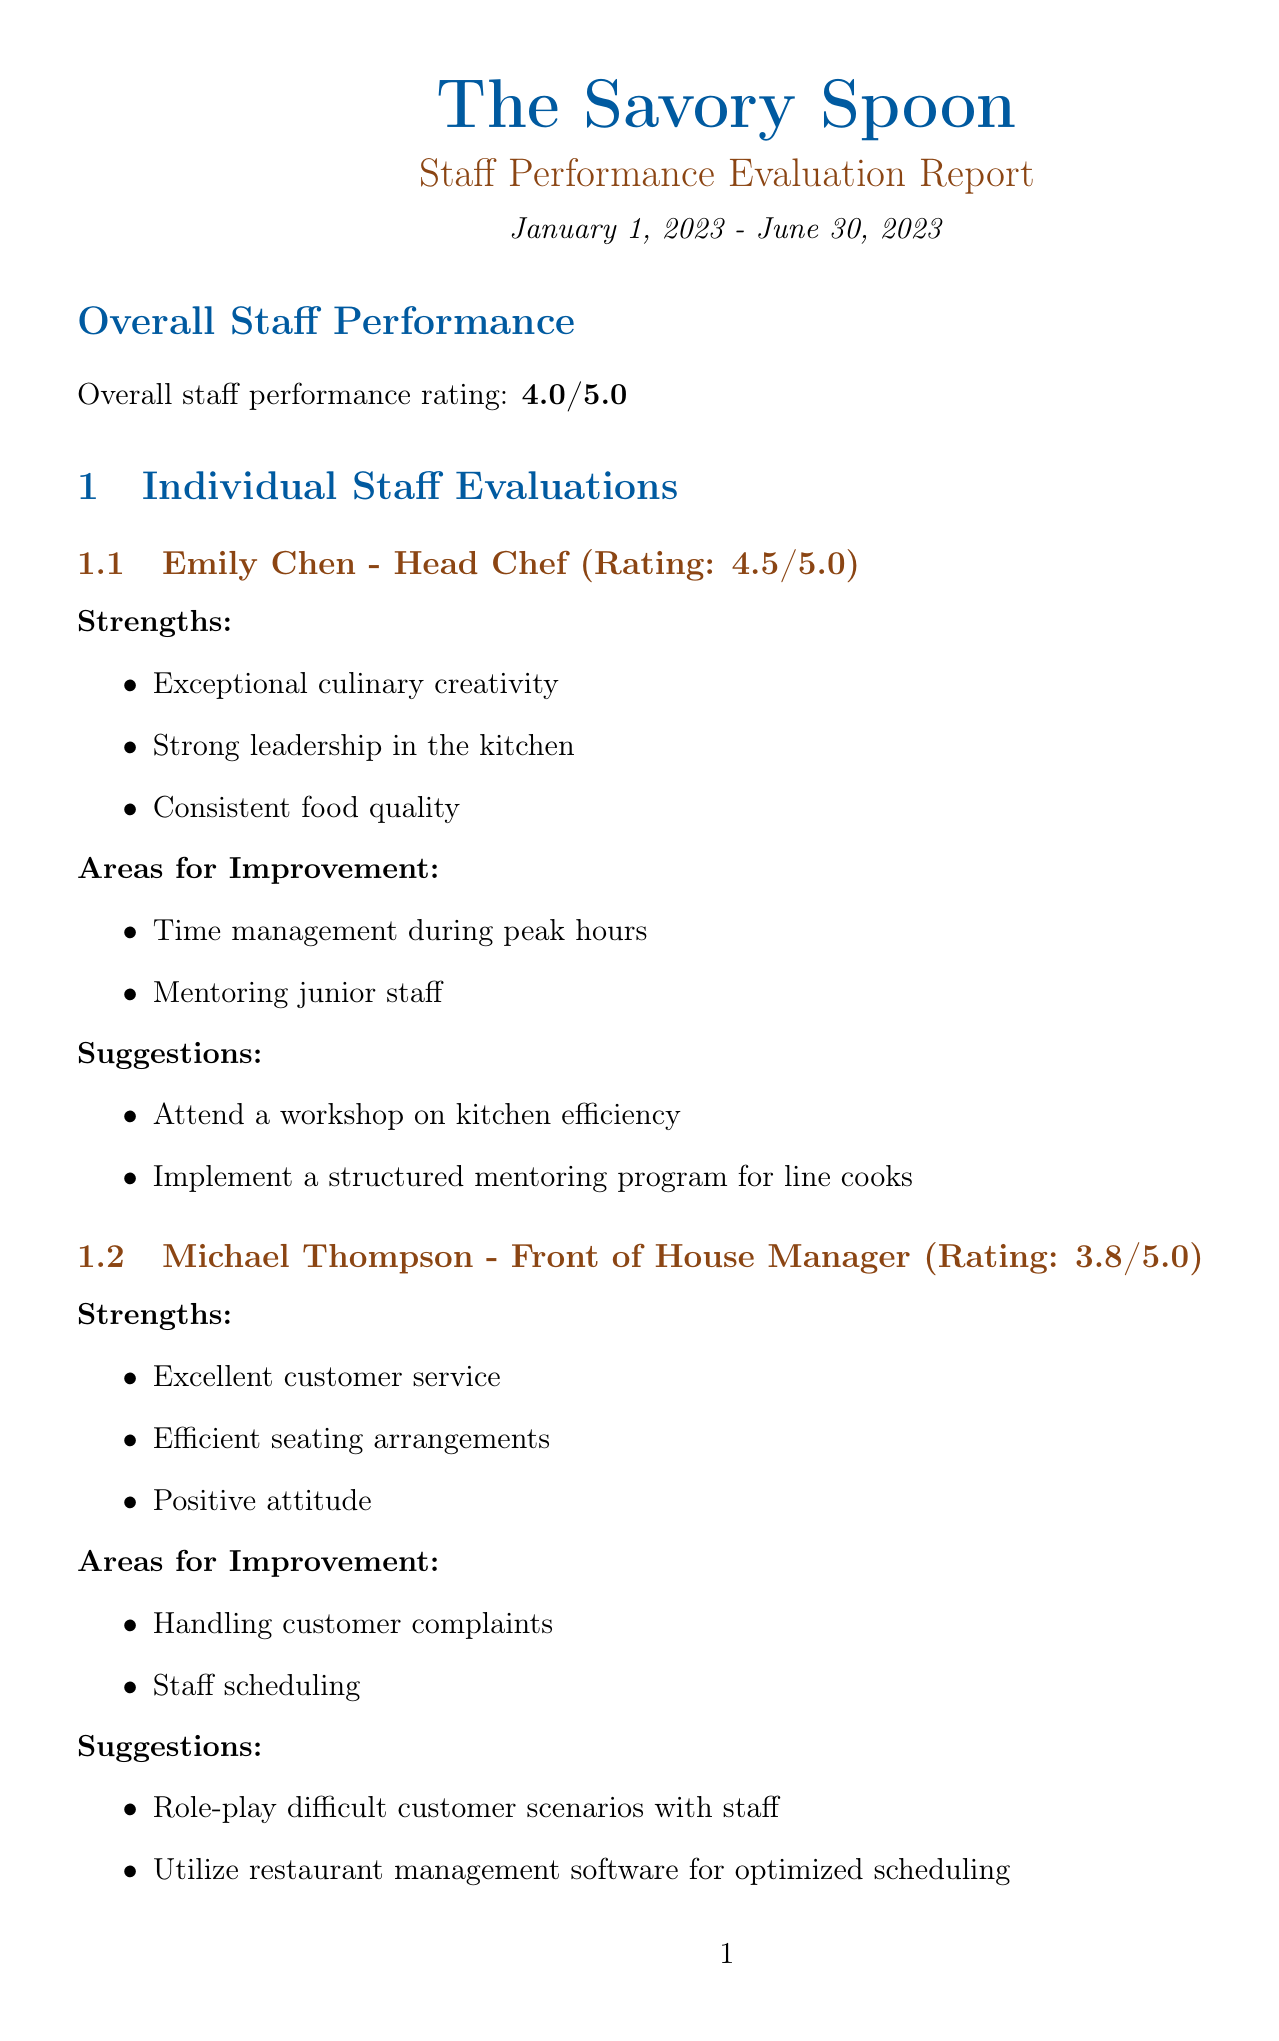What is the overall staff performance rating? The overall staff performance rating is summarized in the report section, which states "Overall staff performance rating: 4.0/5.0."
Answer: 4.0/5.0 Who is the Head Chef? The section on individual staff evaluations provides the name of the person holding that position, which is "Emily Chen."
Answer: Emily Chen What are two strengths of Michael Thompson? The document lists strengths for Michael Thompson as "Excellent customer service," "Efficient seating arrangements," and "Positive attitude."
Answer: Excellent customer service, Efficient seating arrangements What is one area for improvement for Sofia Gonzalez? The report specifies areas for improvement for Sofia Gonzalez, including "Teamwork with kitchen staff" and "Maintaining a clean bar area during rush hours."
Answer: Teamwork with kitchen staff What action plan item focuses on employee morale? The action plan section includes multiple items. One of them directly addresses morale by stating, "Introduce an employee recognition program to boost morale."
Answer: Introduce an employee recognition program to boost morale How many staff are evaluated in the report? The staff evaluations section lists four individual evaluations and details for each, which indicates the total number of staff evaluated.
Answer: Four What is one area of concern mentioned in customer feedback? The customer feedback summary highlights various areas of concern, one of which is "Inconsistent service speed."
Answer: Inconsistent service speed What suggestion is made for improving David Patel's service speed? The suggestions section for David Patel indicates that he can "Practice time management techniques to improve service speed."
Answer: Practice time management techniques to improve service speed 